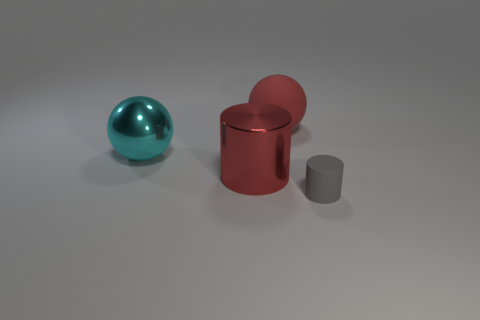Subtract all red spheres. How many spheres are left? 1 Subtract 1 cylinders. How many cylinders are left? 1 Add 2 small gray metal cylinders. How many objects exist? 6 Subtract all cyan blocks. How many blue balls are left? 0 Subtract all small yellow rubber blocks. Subtract all red shiny objects. How many objects are left? 3 Add 3 tiny matte cylinders. How many tiny matte cylinders are left? 4 Add 2 small brown matte balls. How many small brown matte balls exist? 2 Subtract 0 yellow cylinders. How many objects are left? 4 Subtract all gray cylinders. Subtract all green balls. How many cylinders are left? 1 